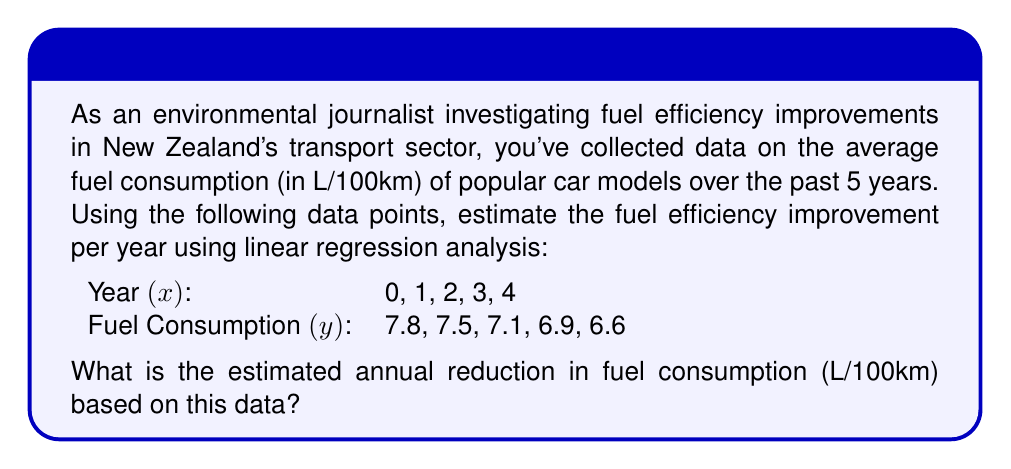Can you answer this question? To estimate the fuel efficiency improvement per year using linear regression, we'll follow these steps:

1. Calculate the means of x and y:
   $\bar{x} = \frac{0 + 1 + 2 + 3 + 4}{5} = 2$
   $\bar{y} = \frac{7.8 + 7.5 + 7.1 + 6.9 + 6.6}{5} = 7.18$

2. Calculate the slope (m) using the formula:
   $m = \frac{\sum(x_i - \bar{x})(y_i - \bar{y})}{\sum(x_i - \bar{x})^2}$

3. Compute the numerator and denominator:
   Numerator: $(-2)(0.62) + (-1)(0.32) + (0)(-0.08) + (1)(-0.28) + (2)(-0.58) = -2.34$
   Denominator: $(-2)^2 + (-1)^2 + (0)^2 + (1)^2 + (2)^2 = 10$

4. Calculate the slope:
   $m = \frac{-2.34}{10} = -0.234$

The negative slope indicates a decrease in fuel consumption over time. The magnitude of the slope, 0.234, represents the estimated annual reduction in fuel consumption in L/100km.
Answer: 0.234 L/100km per year 